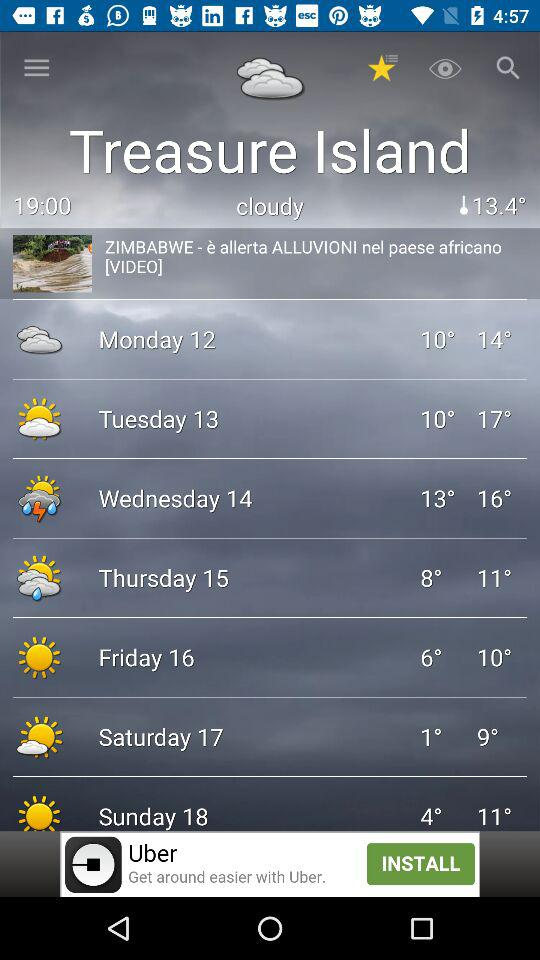What is the current location? The current location is Zimbabwe. 